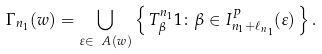<formula> <loc_0><loc_0><loc_500><loc_500>\Gamma _ { n _ { 1 } } ( w ) = \bigcup _ { \varepsilon \in \ A ( w ) } \left \{ \, T _ { \beta } ^ { n _ { 1 } } 1 \colon \beta \in I _ { n _ { 1 } + \ell _ { n _ { 1 } } } ^ { P } ( \varepsilon ) \, \right \} .</formula> 